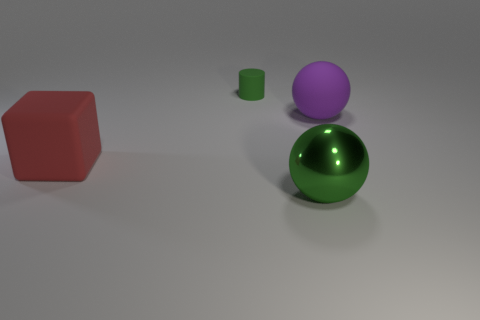What is the material or texture of the objects? The objects appear to be rendered with different finishes. The red cube and purple sphere have a matte finish that diffuses light, while the green sphere and cylinder have a reflective, rubber-like surface that catches the light and displays highlights and reflections. 